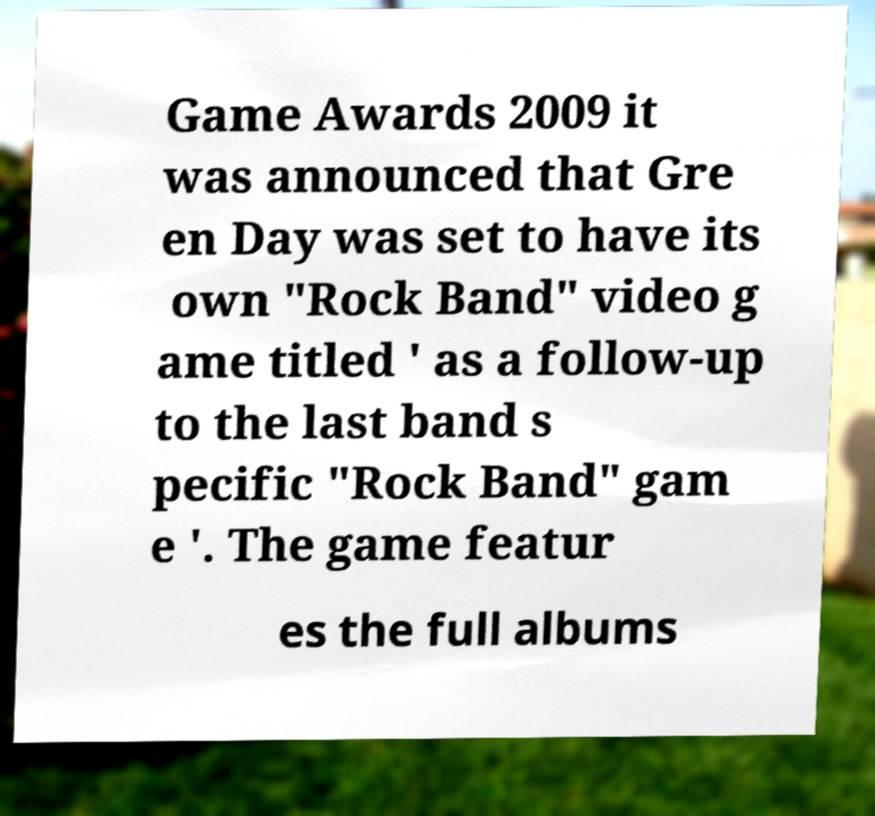For documentation purposes, I need the text within this image transcribed. Could you provide that? Game Awards 2009 it was announced that Gre en Day was set to have its own "Rock Band" video g ame titled ' as a follow-up to the last band s pecific "Rock Band" gam e '. The game featur es the full albums 